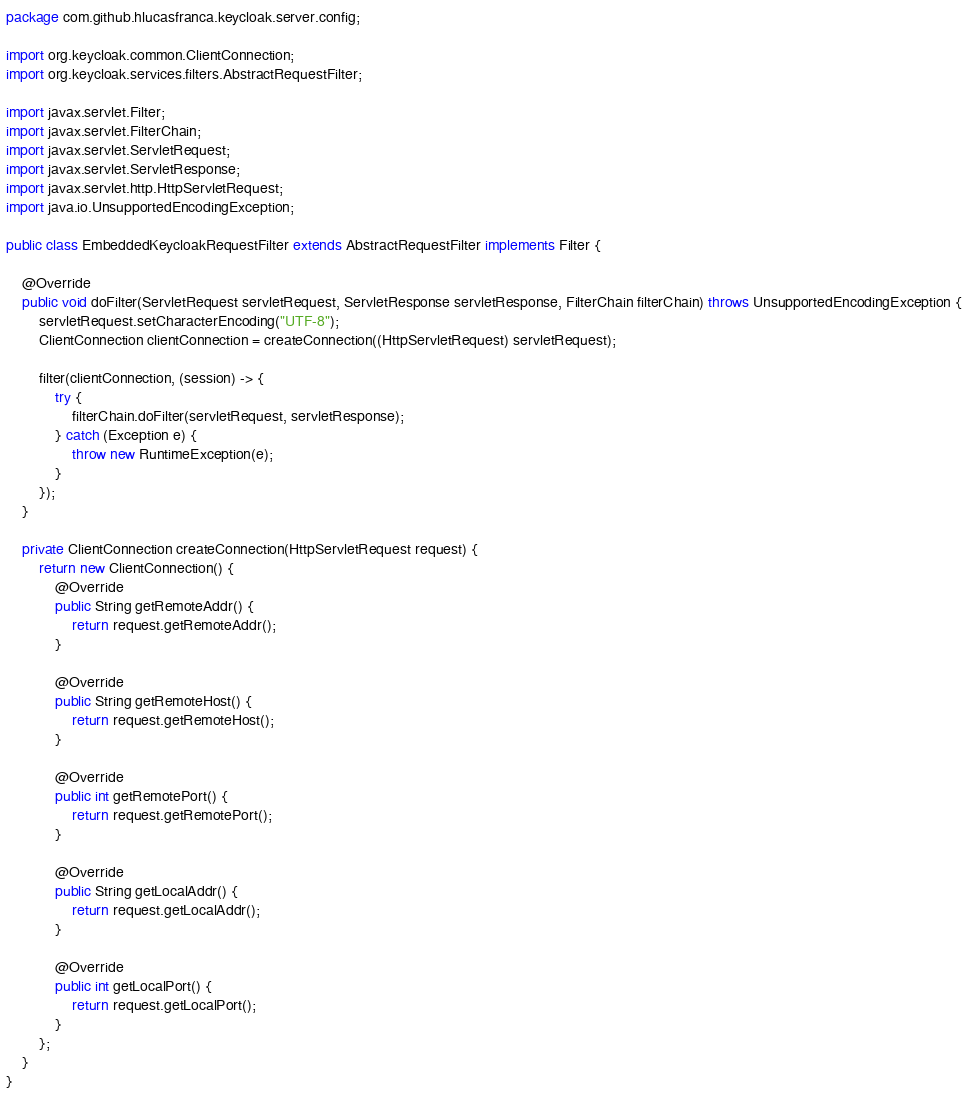<code> <loc_0><loc_0><loc_500><loc_500><_Java_>package com.github.hlucasfranca.keycloak.server.config;

import org.keycloak.common.ClientConnection;
import org.keycloak.services.filters.AbstractRequestFilter;

import javax.servlet.Filter;
import javax.servlet.FilterChain;
import javax.servlet.ServletRequest;
import javax.servlet.ServletResponse;
import javax.servlet.http.HttpServletRequest;
import java.io.UnsupportedEncodingException;

public class EmbeddedKeycloakRequestFilter extends AbstractRequestFilter implements Filter {

    @Override
    public void doFilter(ServletRequest servletRequest, ServletResponse servletResponse, FilterChain filterChain) throws UnsupportedEncodingException {
        servletRequest.setCharacterEncoding("UTF-8");
        ClientConnection clientConnection = createConnection((HttpServletRequest) servletRequest);

        filter(clientConnection, (session) -> {
            try {
                filterChain.doFilter(servletRequest, servletResponse);
            } catch (Exception e) {
                throw new RuntimeException(e);
            }
        });
    }

    private ClientConnection createConnection(HttpServletRequest request) {
        return new ClientConnection() {
            @Override
            public String getRemoteAddr() {
                return request.getRemoteAddr();
            }

            @Override
            public String getRemoteHost() {
                return request.getRemoteHost();
            }

            @Override
            public int getRemotePort() {
                return request.getRemotePort();
            }

            @Override
            public String getLocalAddr() {
                return request.getLocalAddr();
            }

            @Override
            public int getLocalPort() {
                return request.getLocalPort();
            }
        };
    }
}
</code> 